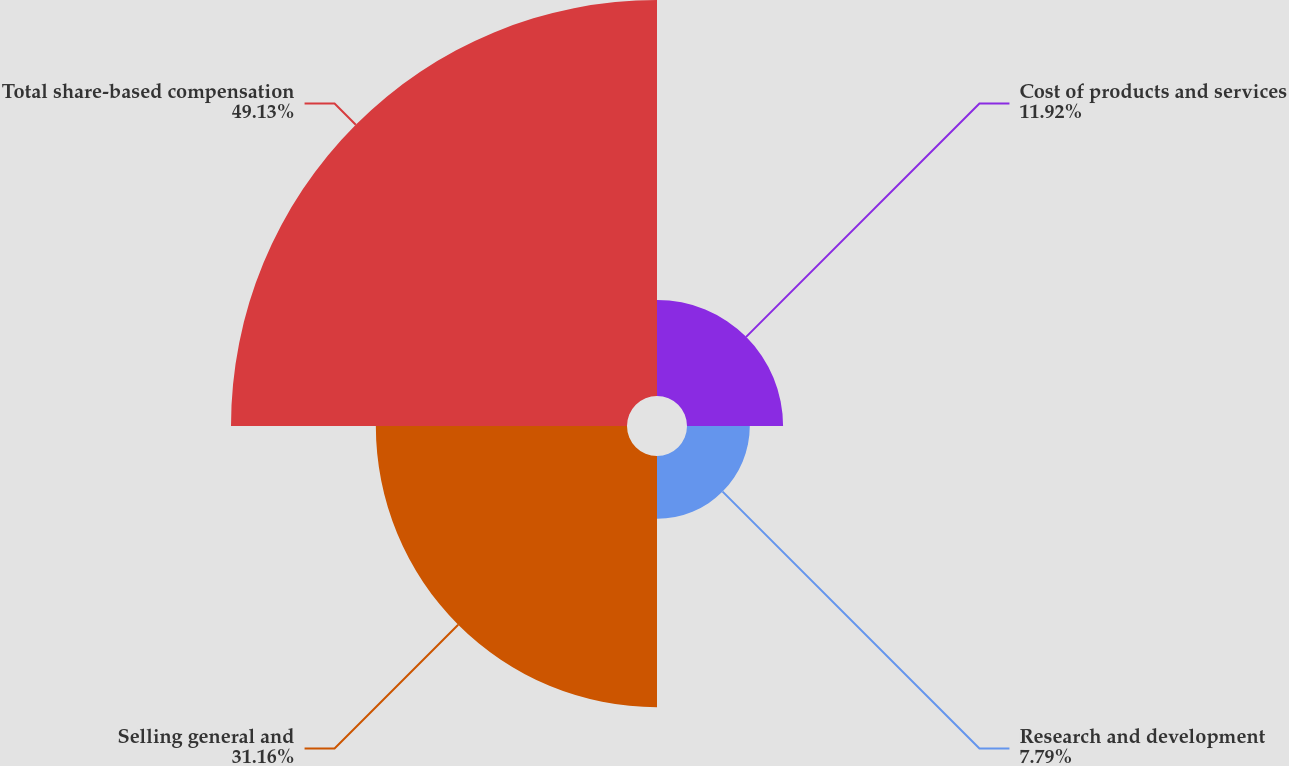Convert chart to OTSL. <chart><loc_0><loc_0><loc_500><loc_500><pie_chart><fcel>Cost of products and services<fcel>Research and development<fcel>Selling general and<fcel>Total share-based compensation<nl><fcel>11.92%<fcel>7.79%<fcel>31.16%<fcel>49.13%<nl></chart> 